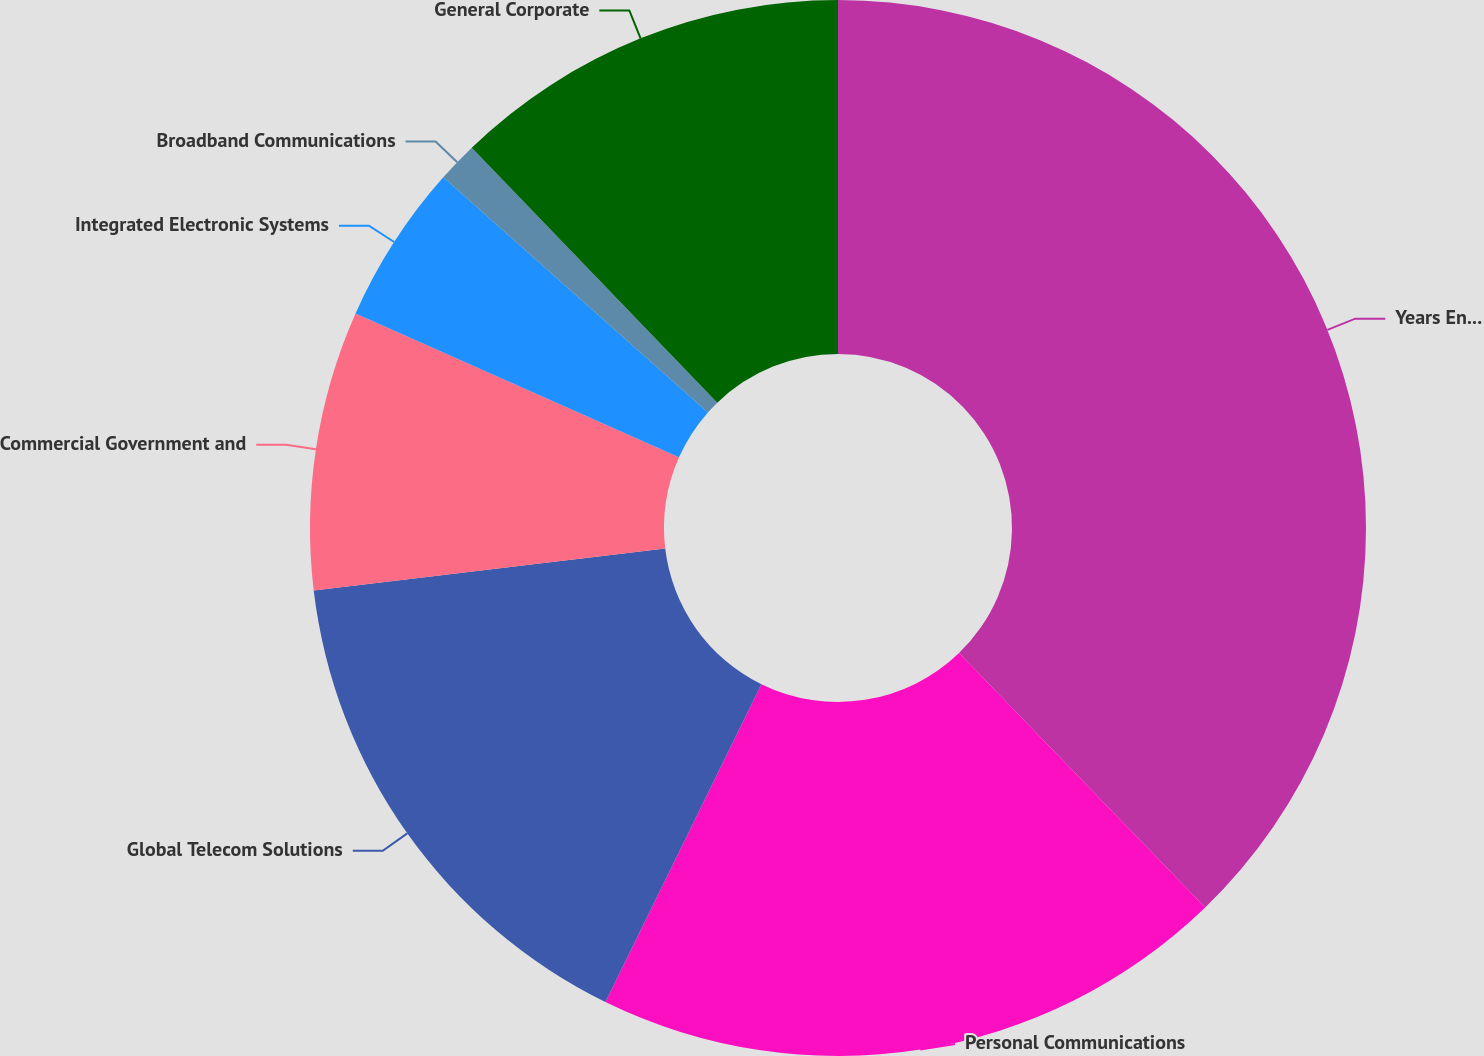Convert chart. <chart><loc_0><loc_0><loc_500><loc_500><pie_chart><fcel>Years Ended December 31<fcel>Personal Communications<fcel>Global Telecom Solutions<fcel>Commercial Government and<fcel>Integrated Electronic Systems<fcel>Broadband Communications<fcel>General Corporate<nl><fcel>37.76%<fcel>19.5%<fcel>15.85%<fcel>8.55%<fcel>4.9%<fcel>1.24%<fcel>12.2%<nl></chart> 